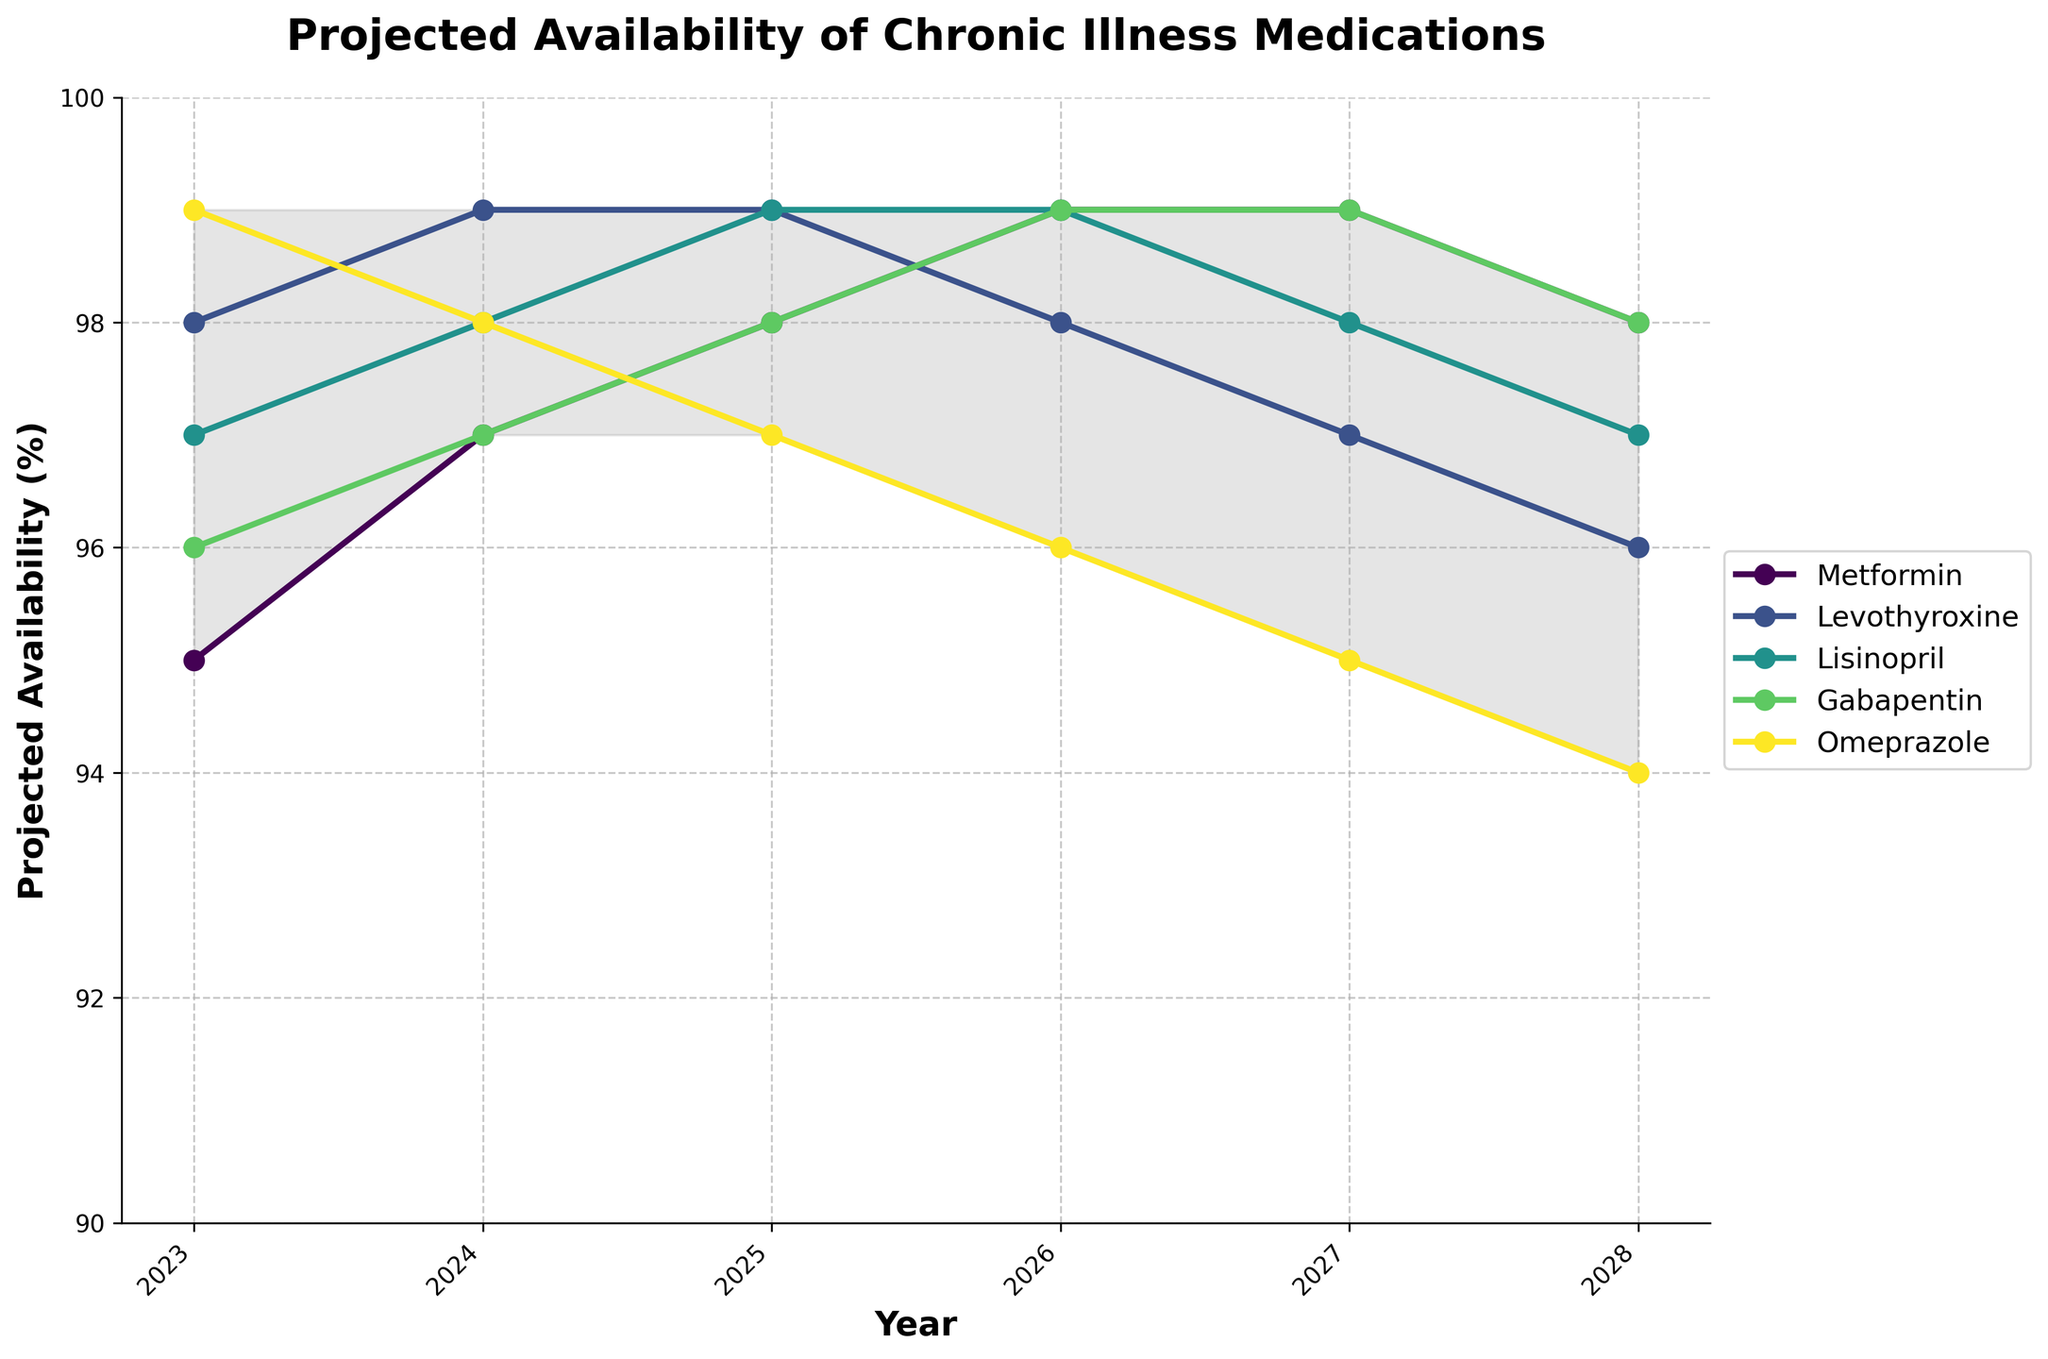What is the title of the chart? The title is usually found at the top of the chart. In this case, the chart is titled "Projected Availability of Chronic Illness Medications" as noted in the code.
Answer: Projected Availability of Chronic Illness Medications What years are covered in this chart? To find the years covered in the chart, look at the x-axis labels. They range from 2023 to 2028.
Answer: 2023 to 2028 Which medication has the highest projected availability in 2025? To determine the highest projected availability, look at the data points for each medication in 2025. Metformin, Levothyroxine, and Lisinopril each have a value of 99 in 2025.
Answer: Metformin, Levothyroxine, Lisinopril Which medication shows a decreasing trend in availability over the 5 years? To identify a decreasing trend, look for the medications where the value decreases over the years. Omeprazole shows a decreasing trend.
Answer: Omeprazole What is the minimum projected availability for Gabapentin over the 5-year period? To find the minimum availability, look at the data points for Gabapentin from 2023 to 2028. The minimum value is 96 in 2023.
Answer: 96 In which year is the availability of Levothyroxine expected to decrease? To find this information, track the values for Levothyroxine across the years. It decreases from 99 in 2025 to 98 in 2026.
Answer: 2026 What is the difference in projected availability between Metformin and Gabapentin in 2027? Subtract the projected availability values of Gabapentin from Metformin in 2027 (99 - 99).
Answer: 0 Which medication has the smallest range of availability across the years? To determine the smallest range, calculate the range (max - min) for each medication. Levothyroxine ranges from 96 to 99, which is a range of 3.
Answer: Levothyroxine How many medications are plotted on the chart? Count the number of medications listed in the data columns (Metformin, Levothyroxine, Lisinopril, Gabapentin, Omeprazole). There are 5.
Answer: 5 What trend do you observe for Omeprazole over the years? To observe the trend, note the values for Omeprazole each year. The trend is a continuous decrease from 99 in 2023 to 94 in 2028.
Answer: Continuous decrease 